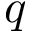Convert formula to latex. <formula><loc_0><loc_0><loc_500><loc_500>q</formula> 